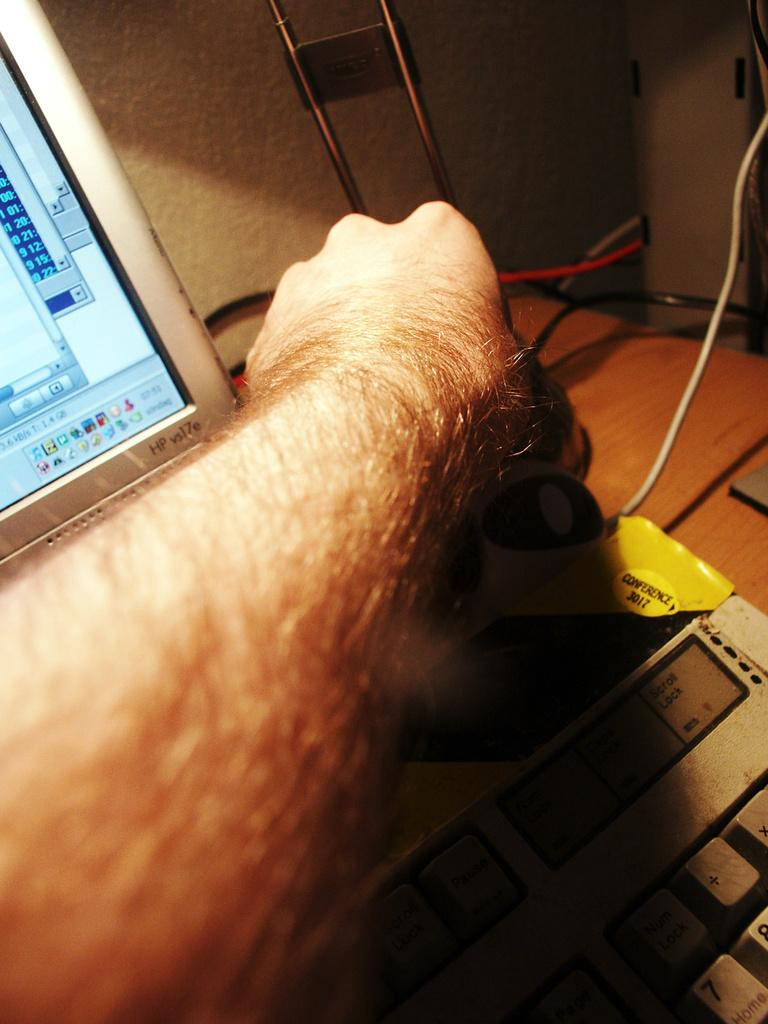<image>
Share a concise interpretation of the image provided. A conference 3017 yellow sticker on a keyboard next to a really hairy arm. 